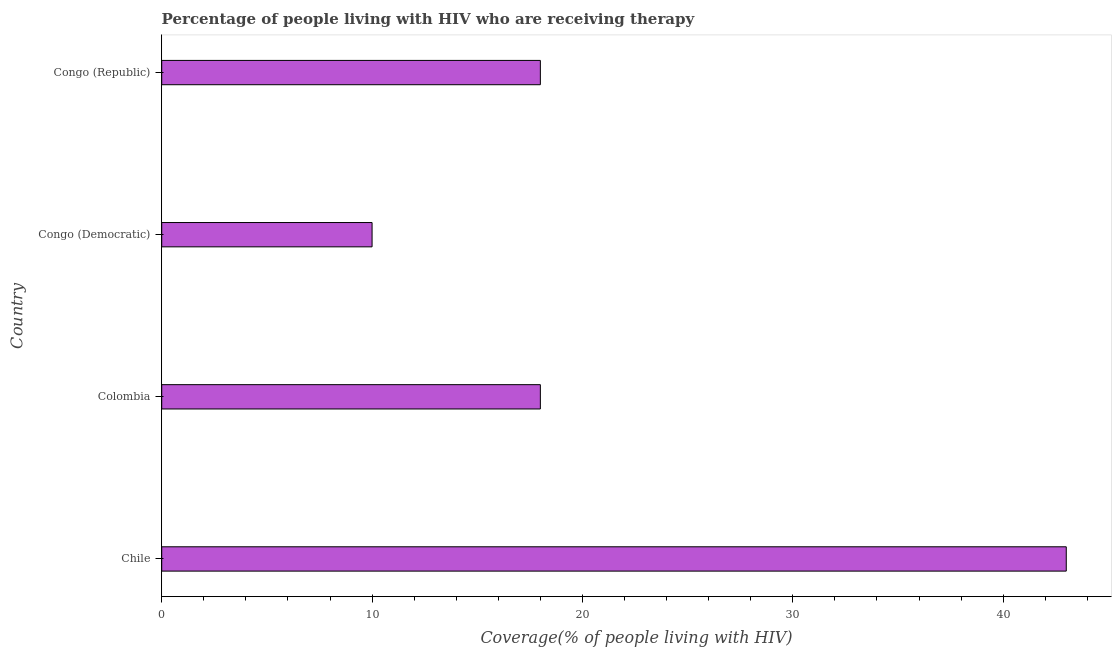Does the graph contain grids?
Your response must be concise. No. What is the title of the graph?
Provide a short and direct response. Percentage of people living with HIV who are receiving therapy. What is the label or title of the X-axis?
Your answer should be very brief. Coverage(% of people living with HIV). What is the label or title of the Y-axis?
Offer a terse response. Country. What is the antiretroviral therapy coverage in Chile?
Give a very brief answer. 43. In which country was the antiretroviral therapy coverage minimum?
Keep it short and to the point. Congo (Democratic). What is the sum of the antiretroviral therapy coverage?
Offer a very short reply. 89. What is the average antiretroviral therapy coverage per country?
Provide a succinct answer. 22.25. In how many countries, is the antiretroviral therapy coverage greater than 20 %?
Offer a terse response. 1. What is the ratio of the antiretroviral therapy coverage in Chile to that in Congo (Democratic)?
Offer a terse response. 4.3. Is the antiretroviral therapy coverage in Chile less than that in Congo (Democratic)?
Make the answer very short. No. Is the difference between the antiretroviral therapy coverage in Chile and Congo (Democratic) greater than the difference between any two countries?
Ensure brevity in your answer.  Yes. In how many countries, is the antiretroviral therapy coverage greater than the average antiretroviral therapy coverage taken over all countries?
Offer a terse response. 1. How many bars are there?
Give a very brief answer. 4. Are all the bars in the graph horizontal?
Ensure brevity in your answer.  Yes. How many countries are there in the graph?
Give a very brief answer. 4. What is the difference between two consecutive major ticks on the X-axis?
Make the answer very short. 10. Are the values on the major ticks of X-axis written in scientific E-notation?
Offer a terse response. No. What is the Coverage(% of people living with HIV) in Colombia?
Your answer should be compact. 18. What is the difference between the Coverage(% of people living with HIV) in Chile and Colombia?
Offer a very short reply. 25. What is the difference between the Coverage(% of people living with HIV) in Chile and Congo (Democratic)?
Ensure brevity in your answer.  33. What is the difference between the Coverage(% of people living with HIV) in Colombia and Congo (Democratic)?
Make the answer very short. 8. What is the difference between the Coverage(% of people living with HIV) in Colombia and Congo (Republic)?
Offer a terse response. 0. What is the difference between the Coverage(% of people living with HIV) in Congo (Democratic) and Congo (Republic)?
Make the answer very short. -8. What is the ratio of the Coverage(% of people living with HIV) in Chile to that in Colombia?
Offer a terse response. 2.39. What is the ratio of the Coverage(% of people living with HIV) in Chile to that in Congo (Republic)?
Make the answer very short. 2.39. What is the ratio of the Coverage(% of people living with HIV) in Colombia to that in Congo (Democratic)?
Your answer should be very brief. 1.8. What is the ratio of the Coverage(% of people living with HIV) in Congo (Democratic) to that in Congo (Republic)?
Keep it short and to the point. 0.56. 